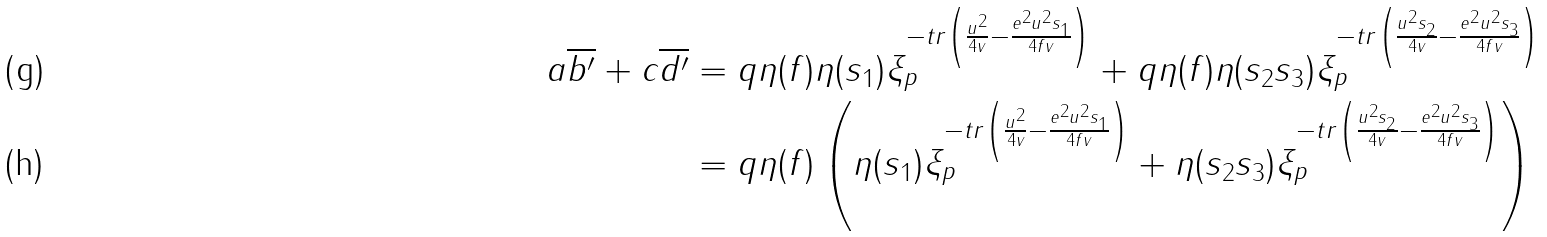Convert formula to latex. <formula><loc_0><loc_0><loc_500><loc_500>a \overline { b ^ { \prime } } + c \overline { d ^ { \prime } } & = q \eta ( f ) \eta ( s _ { 1 } ) \xi _ { p } ^ { - t r \left ( \frac { u ^ { 2 } } { 4 v } - \frac { e ^ { 2 } u ^ { 2 } s _ { 1 } } { 4 f v } \right ) } + q \eta ( f ) \eta ( s _ { 2 } s _ { 3 } ) \xi _ { p } ^ { - t r \left ( \frac { u ^ { 2 } s _ { 2 } } { 4 v } - \frac { e ^ { 2 } u ^ { 2 } s _ { 3 } } { 4 f v } \right ) } \\ & = q \eta ( f ) \left ( \eta ( s _ { 1 } ) \xi _ { p } ^ { - t r \left ( \frac { u ^ { 2 } } { 4 v } - \frac { e ^ { 2 } u ^ { 2 } s _ { 1 } } { 4 f v } \right ) } + \eta ( s _ { 2 } s _ { 3 } ) \xi _ { p } ^ { - t r \left ( \frac { u ^ { 2 } s _ { 2 } } { 4 v } - \frac { e ^ { 2 } u ^ { 2 } s _ { 3 } } { 4 f v } \right ) } \right )</formula> 